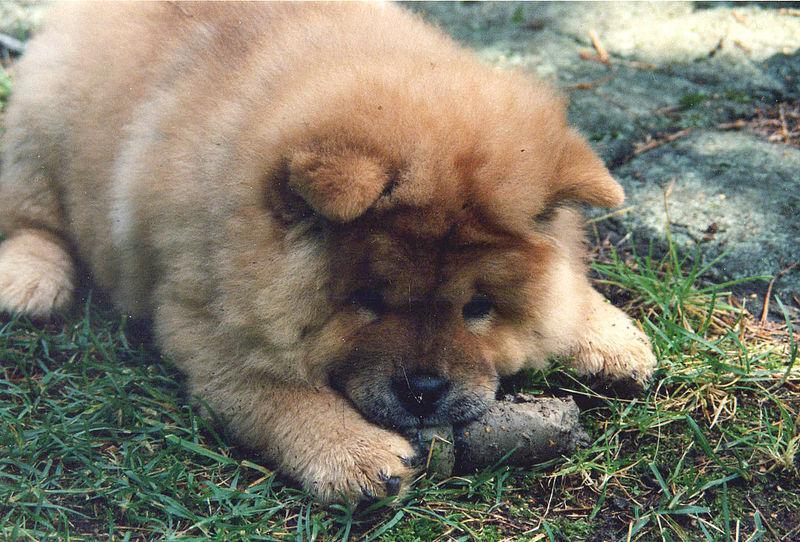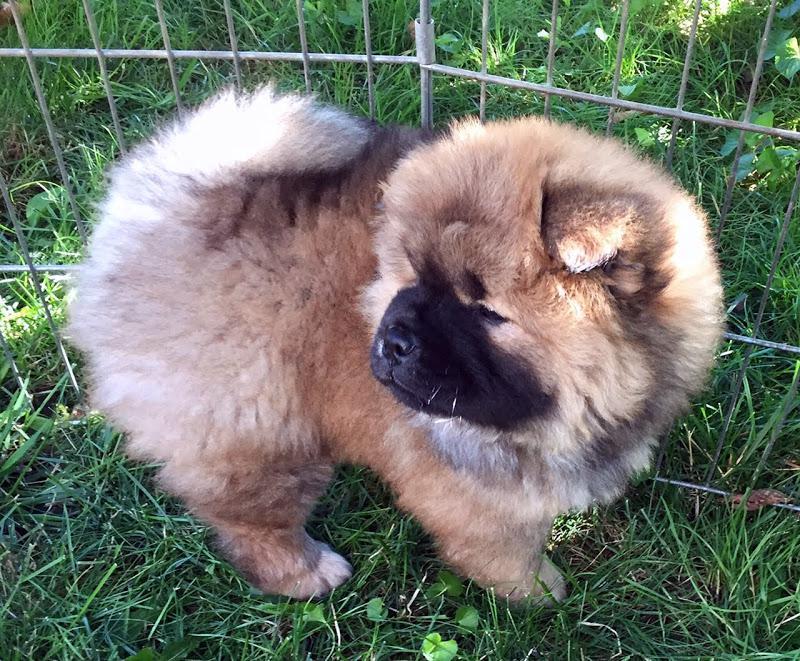The first image is the image on the left, the second image is the image on the right. Analyze the images presented: Is the assertion "There is one fluffy Chow Chow standing, and one fluffy Chow Chow with its face resting on the ground." valid? Answer yes or no. Yes. The first image is the image on the left, the second image is the image on the right. For the images displayed, is the sentence "There are two chow chows outside in the grass." factually correct? Answer yes or no. Yes. 